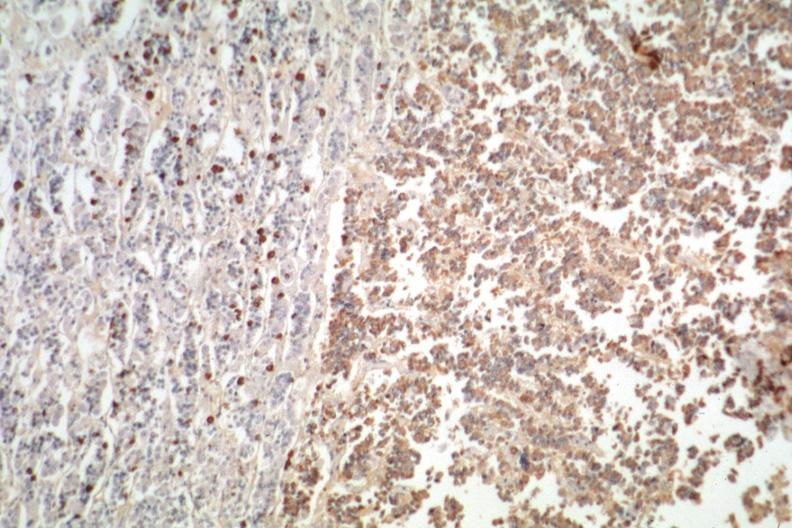s history present?
Answer the question using a single word or phrase. No 